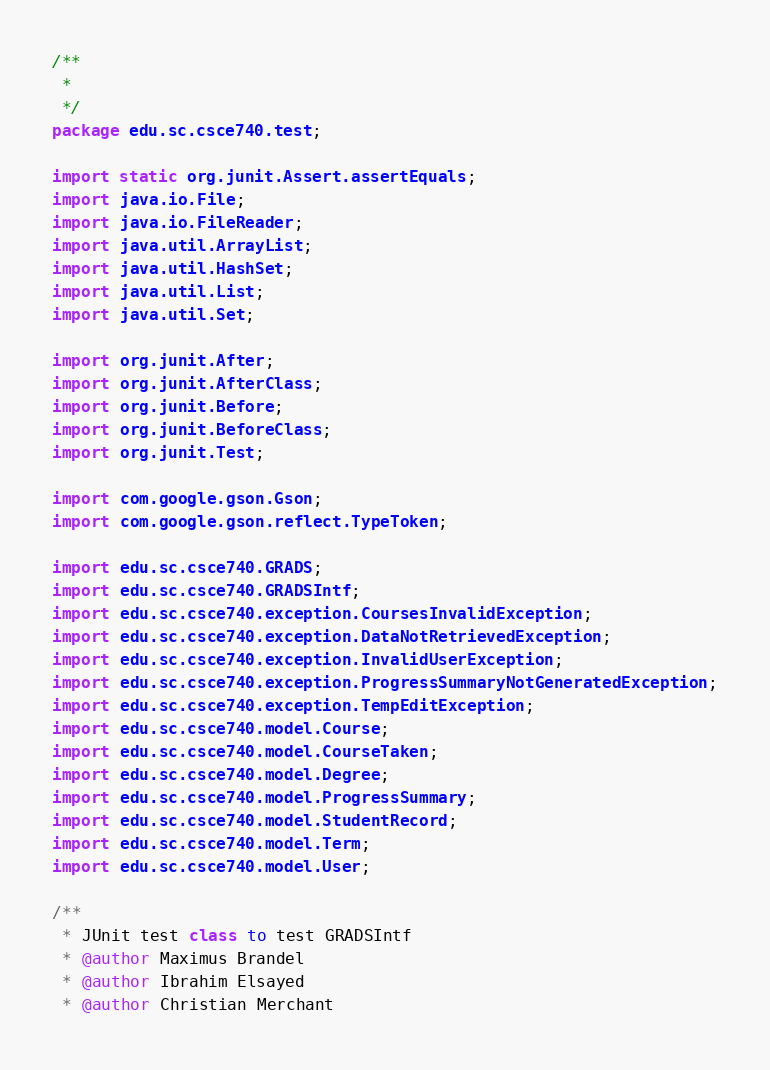Convert code to text. <code><loc_0><loc_0><loc_500><loc_500><_Java_>/**
 * 
 */
package edu.sc.csce740.test;

import static org.junit.Assert.assertEquals;
import java.io.File;
import java.io.FileReader;
import java.util.ArrayList;
import java.util.HashSet;
import java.util.List;
import java.util.Set;

import org.junit.After;
import org.junit.AfterClass;
import org.junit.Before;
import org.junit.BeforeClass;
import org.junit.Test;

import com.google.gson.Gson;
import com.google.gson.reflect.TypeToken;

import edu.sc.csce740.GRADS;
import edu.sc.csce740.GRADSIntf;
import edu.sc.csce740.exception.CoursesInvalidException;
import edu.sc.csce740.exception.DataNotRetrievedException;
import edu.sc.csce740.exception.InvalidUserException;
import edu.sc.csce740.exception.ProgressSummaryNotGeneratedException;
import edu.sc.csce740.exception.TempEditException;
import edu.sc.csce740.model.Course;
import edu.sc.csce740.model.CourseTaken;
import edu.sc.csce740.model.Degree;
import edu.sc.csce740.model.ProgressSummary;
import edu.sc.csce740.model.StudentRecord;
import edu.sc.csce740.model.Term;
import edu.sc.csce740.model.User;

/**
 * JUnit test class to test GRADSIntf
 * @author Maximus Brandel
 * @author Ibrahim Elsayed
 * @author Christian Merchant</code> 